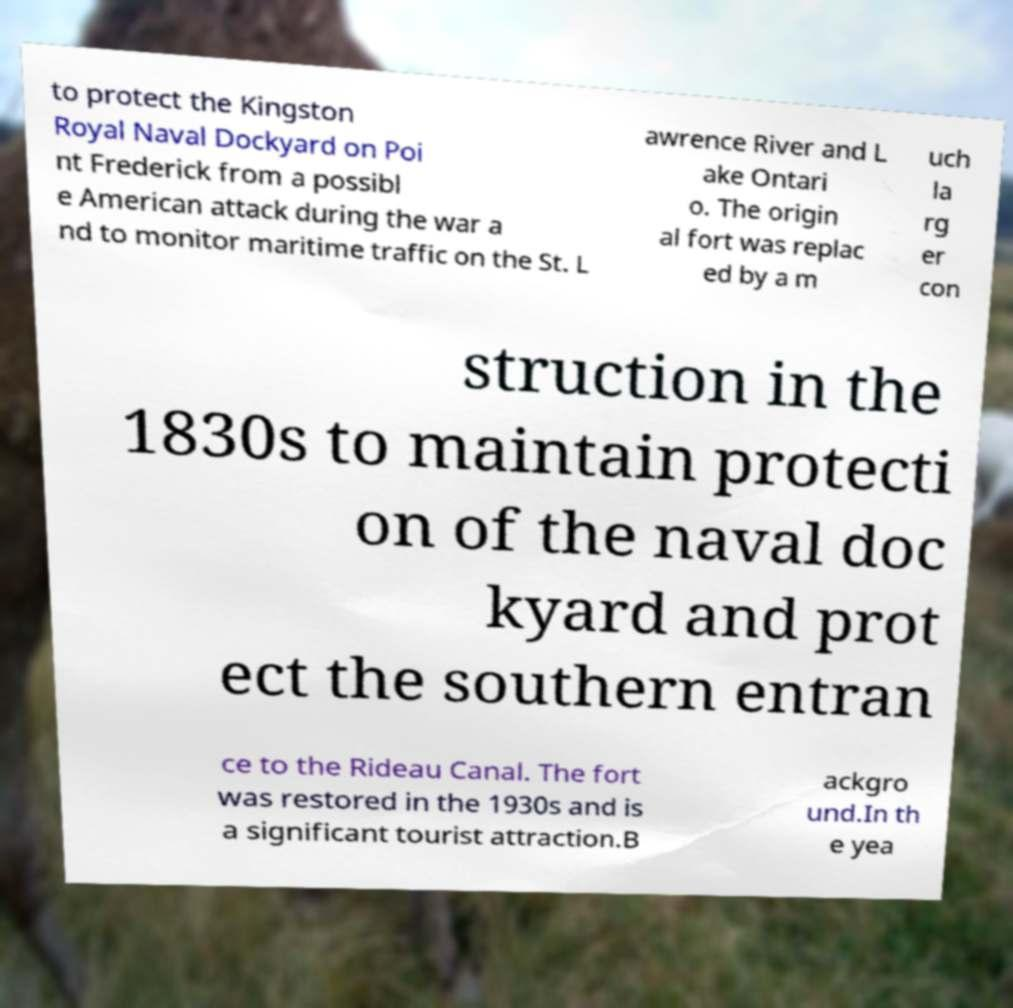What messages or text are displayed in this image? I need them in a readable, typed format. to protect the Kingston Royal Naval Dockyard on Poi nt Frederick from a possibl e American attack during the war a nd to monitor maritime traffic on the St. L awrence River and L ake Ontari o. The origin al fort was replac ed by a m uch la rg er con struction in the 1830s to maintain protecti on of the naval doc kyard and prot ect the southern entran ce to the Rideau Canal. The fort was restored in the 1930s and is a significant tourist attraction.B ackgro und.In th e yea 